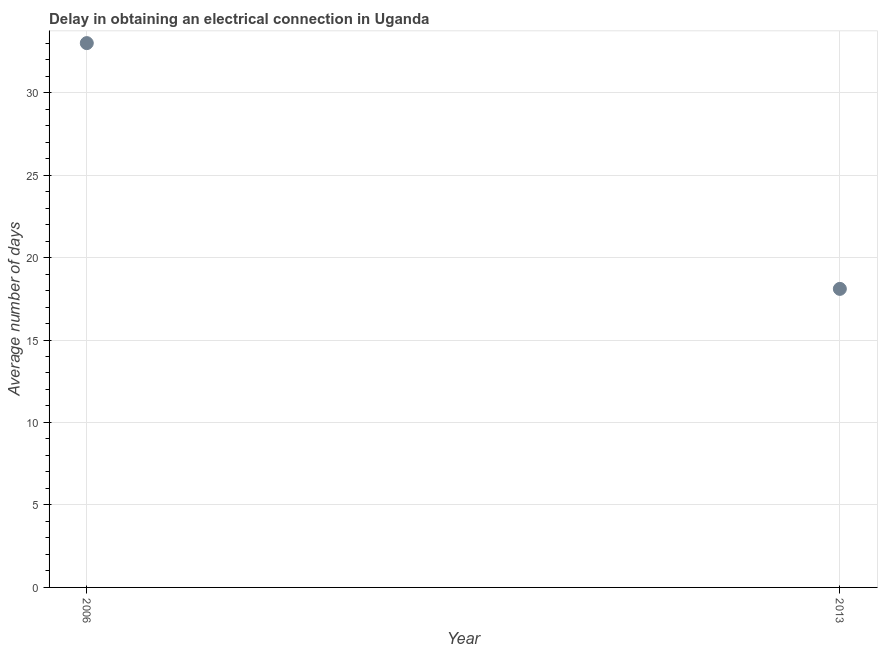Across all years, what is the maximum dalay in electrical connection?
Keep it short and to the point. 33. In which year was the dalay in electrical connection maximum?
Offer a terse response. 2006. What is the sum of the dalay in electrical connection?
Provide a succinct answer. 51.1. What is the difference between the dalay in electrical connection in 2006 and 2013?
Ensure brevity in your answer.  14.9. What is the average dalay in electrical connection per year?
Make the answer very short. 25.55. What is the median dalay in electrical connection?
Ensure brevity in your answer.  25.55. In how many years, is the dalay in electrical connection greater than 1 days?
Give a very brief answer. 2. What is the ratio of the dalay in electrical connection in 2006 to that in 2013?
Give a very brief answer. 1.82. How many dotlines are there?
Offer a terse response. 1. What is the difference between two consecutive major ticks on the Y-axis?
Your answer should be very brief. 5. Are the values on the major ticks of Y-axis written in scientific E-notation?
Offer a very short reply. No. What is the title of the graph?
Give a very brief answer. Delay in obtaining an electrical connection in Uganda. What is the label or title of the Y-axis?
Your response must be concise. Average number of days. What is the Average number of days in 2006?
Offer a very short reply. 33. What is the Average number of days in 2013?
Your response must be concise. 18.1. What is the difference between the Average number of days in 2006 and 2013?
Provide a short and direct response. 14.9. What is the ratio of the Average number of days in 2006 to that in 2013?
Your response must be concise. 1.82. 